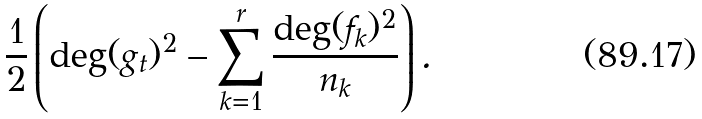Convert formula to latex. <formula><loc_0><loc_0><loc_500><loc_500>\frac { 1 } { 2 } \left ( \deg ( g _ { t } ) ^ { 2 } - \sum _ { k = 1 } ^ { r } \frac { \deg ( f _ { k } ) ^ { 2 } } { n _ { k } } \right ) .</formula> 